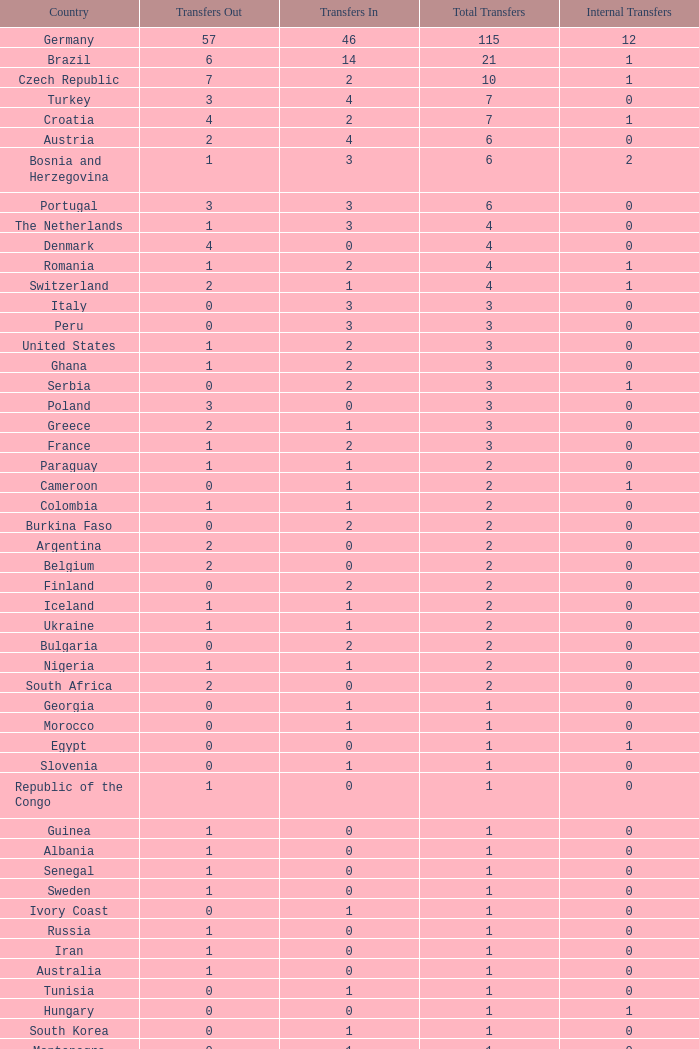What are the transfers in for Hungary? 0.0. 